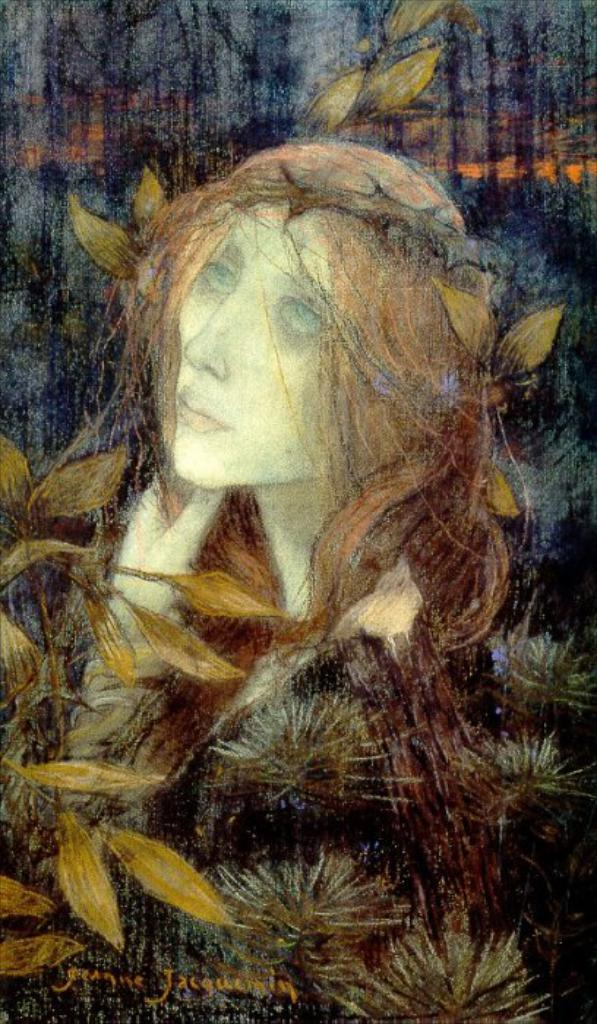What is depicted in the painting in the image? There is a painting of a woman and a painting of a plant in the image. What specific details can be seen in the painting of the plant? There are leaves depicted in the painting. Where is the text located in the image? The text is in the bottom left corner of the image. What type of cord is used to hang the painting in the image? There is no cord visible in the image, as the paintings are not hanging on a wall. 